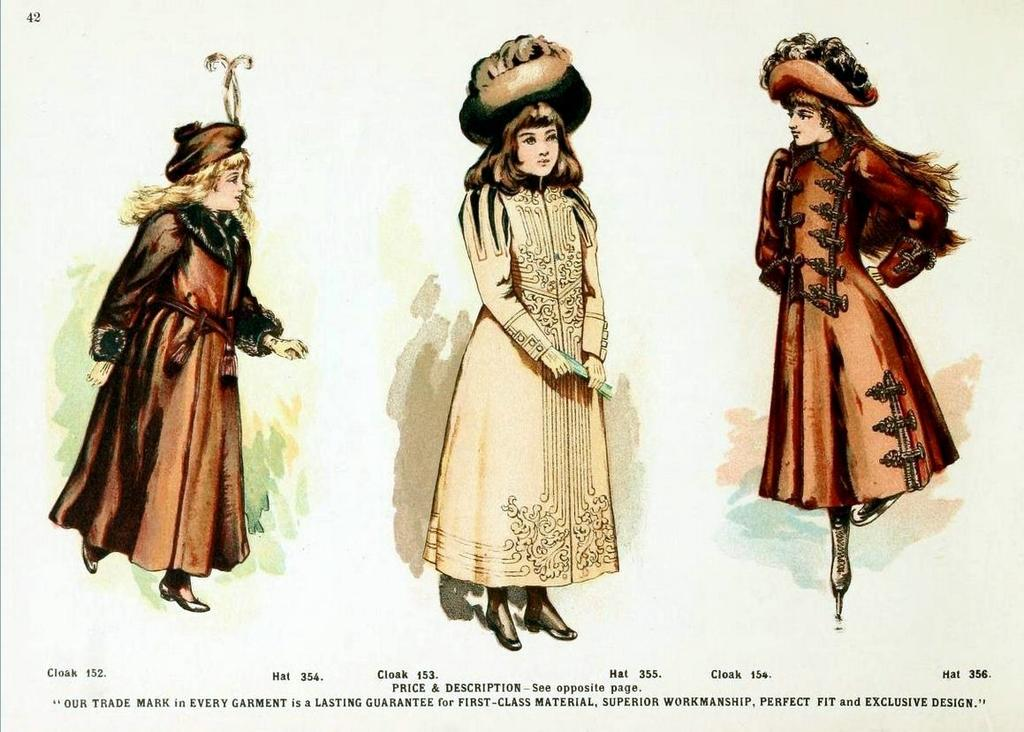What is the main subject of the image? The main subject of the image is an advertisement. What is happening in the advertisement? The advertisement features women standing on the floor. How are the women dressed in the advertisement? The women in the advertisement are wearing different costumes. What are the women talking about in the image? There is no indication in the image that the women are talking, as the focus is on their costumes and standing positions. 